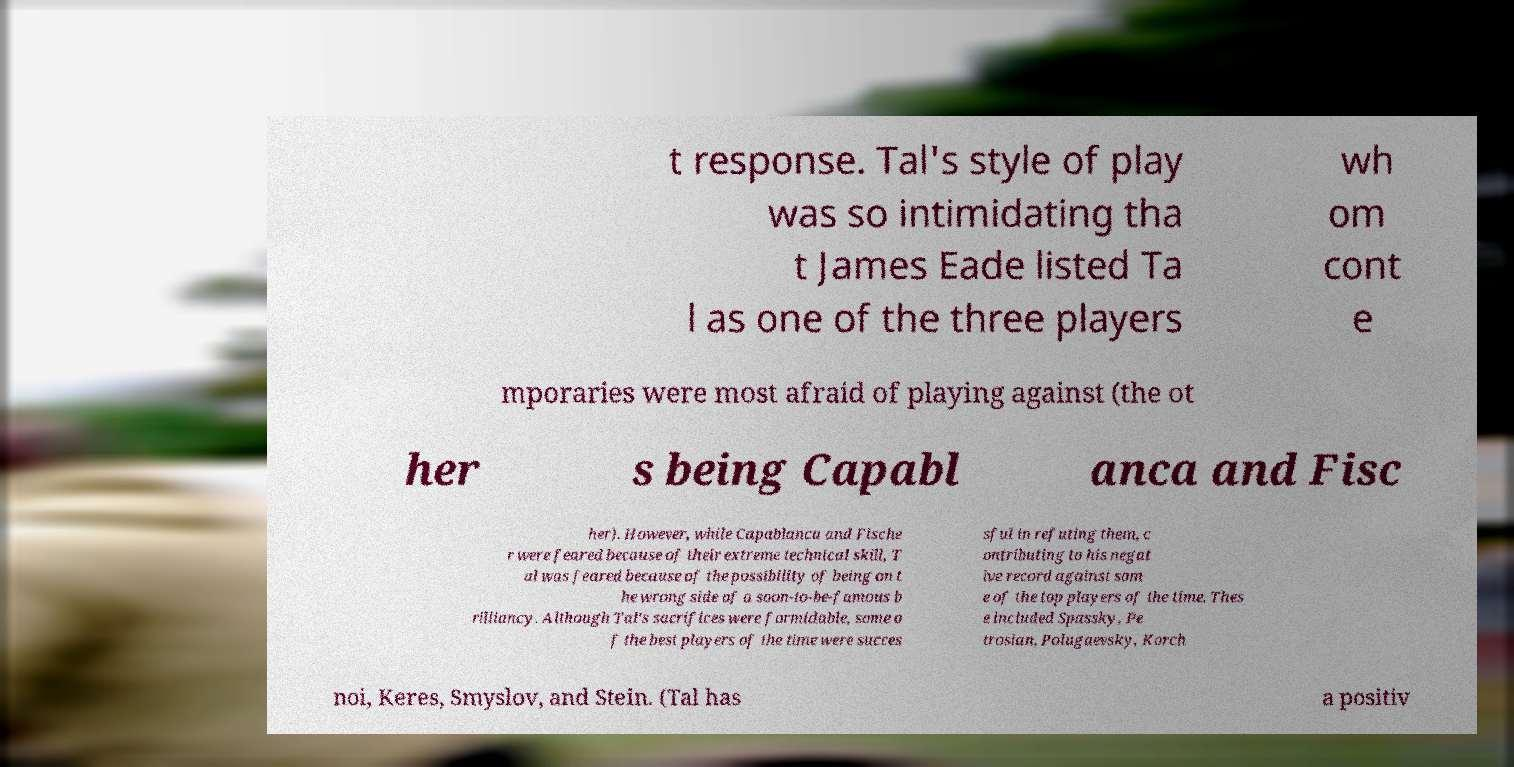For documentation purposes, I need the text within this image transcribed. Could you provide that? t response. Tal's style of play was so intimidating tha t James Eade listed Ta l as one of the three players wh om cont e mporaries were most afraid of playing against (the ot her s being Capabl anca and Fisc her). However, while Capablanca and Fische r were feared because of their extreme technical skill, T al was feared because of the possibility of being on t he wrong side of a soon-to-be-famous b rilliancy. Although Tal's sacrifices were formidable, some o f the best players of the time were succes sful in refuting them, c ontributing to his negat ive record against som e of the top players of the time. Thes e included Spassky, Pe trosian, Polugaevsky, Korch noi, Keres, Smyslov, and Stein. (Tal has a positiv 